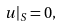<formula> <loc_0><loc_0><loc_500><loc_500>u | _ { S } = 0 ,</formula> 